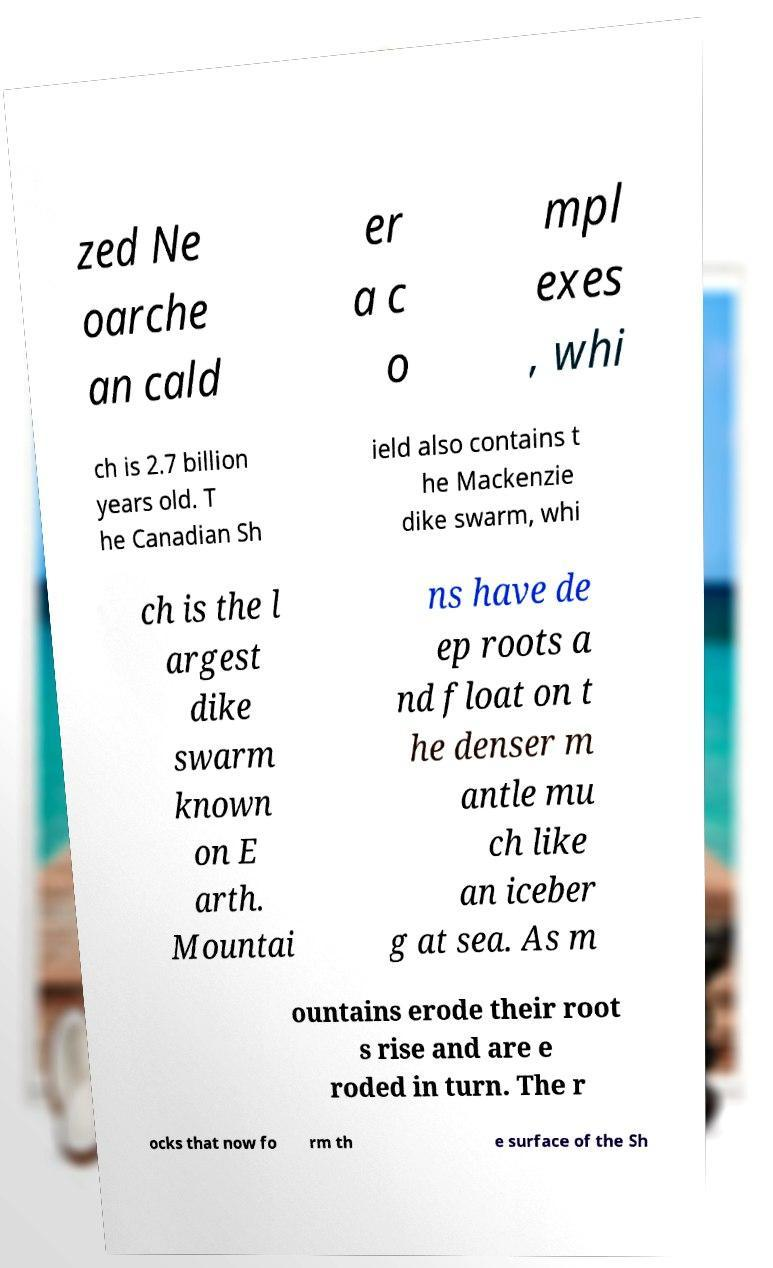There's text embedded in this image that I need extracted. Can you transcribe it verbatim? zed Ne oarche an cald er a c o mpl exes , whi ch is 2.7 billion years old. T he Canadian Sh ield also contains t he Mackenzie dike swarm, whi ch is the l argest dike swarm known on E arth. Mountai ns have de ep roots a nd float on t he denser m antle mu ch like an iceber g at sea. As m ountains erode their root s rise and are e roded in turn. The r ocks that now fo rm th e surface of the Sh 